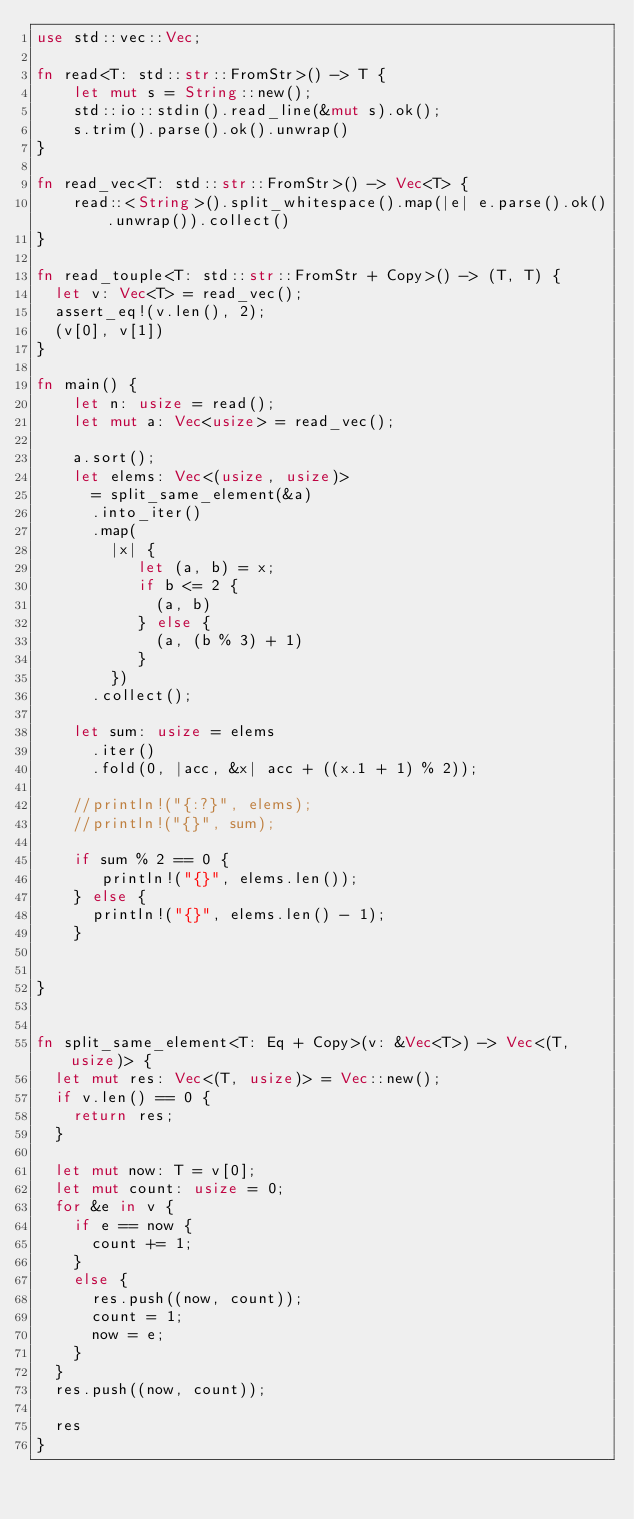Convert code to text. <code><loc_0><loc_0><loc_500><loc_500><_Rust_>use std::vec::Vec;

fn read<T: std::str::FromStr>() -> T {
    let mut s = String::new();
    std::io::stdin().read_line(&mut s).ok();
    s.trim().parse().ok().unwrap()
}

fn read_vec<T: std::str::FromStr>() -> Vec<T> {
    read::<String>().split_whitespace().map(|e| e.parse().ok().unwrap()).collect()
}

fn read_touple<T: std::str::FromStr + Copy>() -> (T, T) {
  let v: Vec<T> = read_vec();
  assert_eq!(v.len(), 2);
  (v[0], v[1])
}

fn main() {
    let n: usize = read();
    let mut a: Vec<usize> = read_vec();

    a.sort();
    let elems: Vec<(usize, usize)> 
      = split_same_element(&a)
      .into_iter()
      .map(
        |x| {
           let (a, b) = x; 
           if b <= 2 { 
             (a, b) 
           } else { 
             (a, (b % 3) + 1) 
           } 
        })
      .collect();

    let sum: usize = elems
      .iter()
      .fold(0, |acc, &x| acc + ((x.1 + 1) % 2));

    //println!("{:?}", elems);
    //println!("{}", sum);

    if sum % 2 == 0 {
       println!("{}", elems.len());
    } else {
      println!("{}", elems.len() - 1);
    }


}


fn split_same_element<T: Eq + Copy>(v: &Vec<T>) -> Vec<(T, usize)> {
  let mut res: Vec<(T, usize)> = Vec::new();
  if v.len() == 0 {
    return res;
  }

  let mut now: T = v[0];
  let mut count: usize = 0;
  for &e in v {
    if e == now {
      count += 1;
    }
    else {
      res.push((now, count));
      count = 1;
      now = e;
    }
  }
  res.push((now, count));

  res
}</code> 